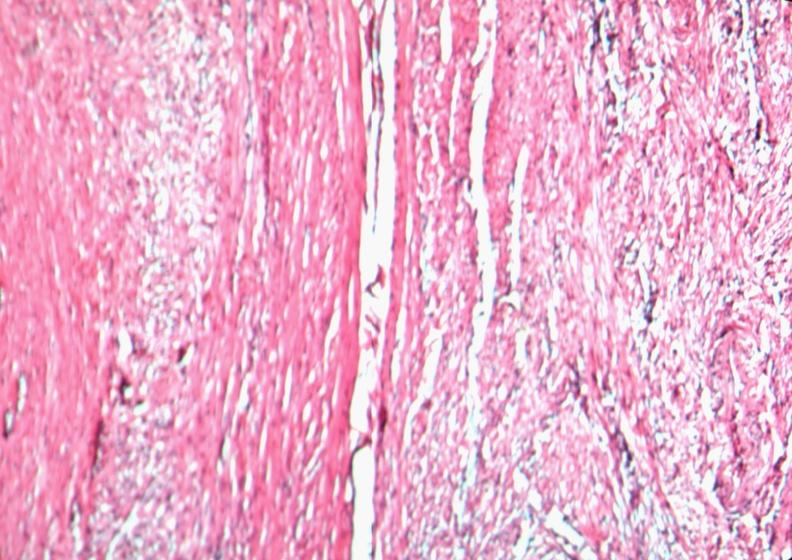does this image show uterus, leiomyoma?
Answer the question using a single word or phrase. Yes 